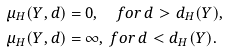<formula> <loc_0><loc_0><loc_500><loc_500>\mu _ { H } ( Y , d ) & = 0 , \quad f o r \, d > d _ { H } ( Y ) , \\ \mu _ { H } ( Y , d ) & = \infty , \, f o r \, d < d _ { H } ( Y ) .</formula> 